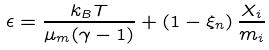<formula> <loc_0><loc_0><loc_500><loc_500>\epsilon = \frac { k _ { B } T } { \mu _ { m } ( \gamma - 1 ) } + \left ( 1 - \xi _ { n } \right ) \frac { X _ { i } } { m _ { i } }</formula> 